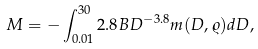Convert formula to latex. <formula><loc_0><loc_0><loc_500><loc_500>M = - \int ^ { 3 0 } _ { 0 . 0 1 } 2 . 8 B D ^ { - 3 . 8 } m ( D , \varrho ) d D ,</formula> 